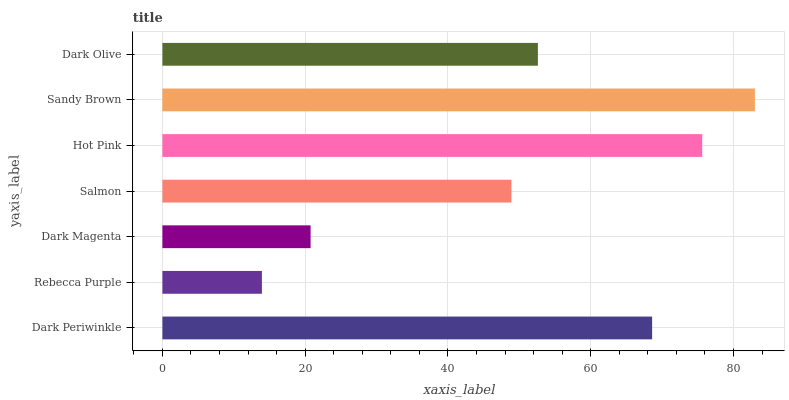Is Rebecca Purple the minimum?
Answer yes or no. Yes. Is Sandy Brown the maximum?
Answer yes or no. Yes. Is Dark Magenta the minimum?
Answer yes or no. No. Is Dark Magenta the maximum?
Answer yes or no. No. Is Dark Magenta greater than Rebecca Purple?
Answer yes or no. Yes. Is Rebecca Purple less than Dark Magenta?
Answer yes or no. Yes. Is Rebecca Purple greater than Dark Magenta?
Answer yes or no. No. Is Dark Magenta less than Rebecca Purple?
Answer yes or no. No. Is Dark Olive the high median?
Answer yes or no. Yes. Is Dark Olive the low median?
Answer yes or no. Yes. Is Dark Periwinkle the high median?
Answer yes or no. No. Is Dark Periwinkle the low median?
Answer yes or no. No. 